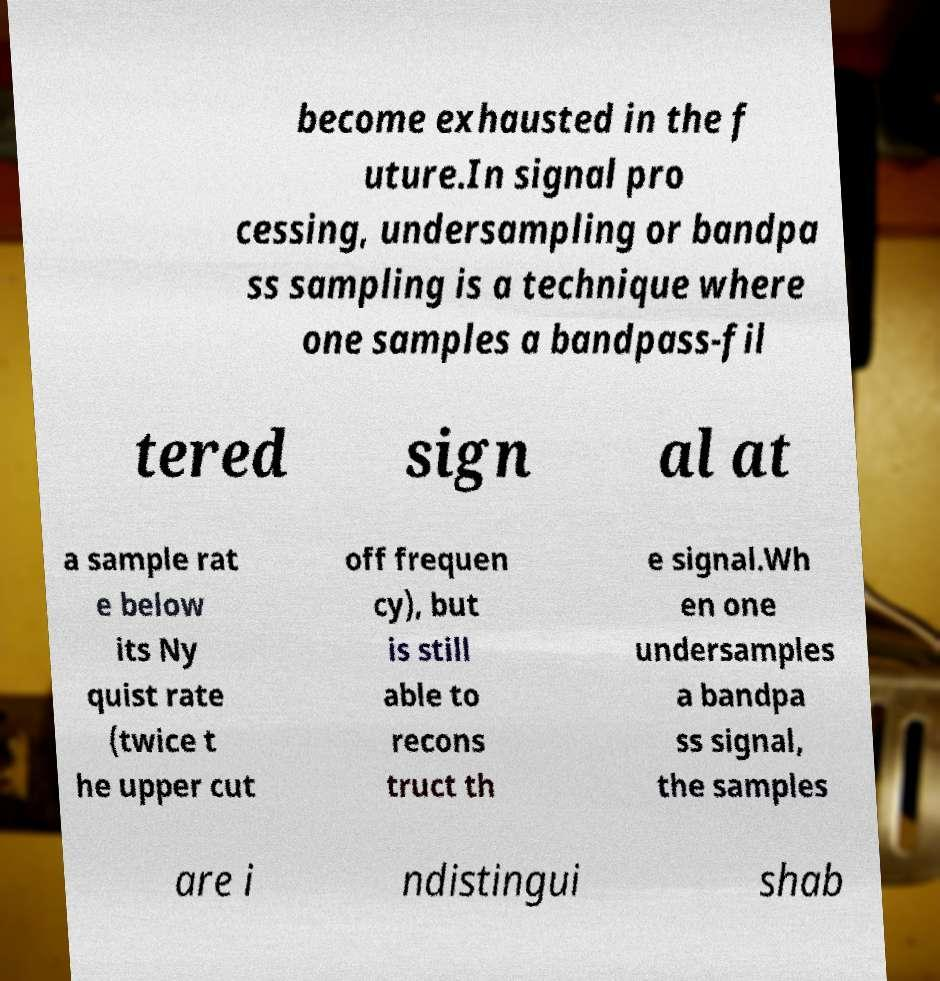Could you assist in decoding the text presented in this image and type it out clearly? become exhausted in the f uture.In signal pro cessing, undersampling or bandpa ss sampling is a technique where one samples a bandpass-fil tered sign al at a sample rat e below its Ny quist rate (twice t he upper cut off frequen cy), but is still able to recons truct th e signal.Wh en one undersamples a bandpa ss signal, the samples are i ndistingui shab 